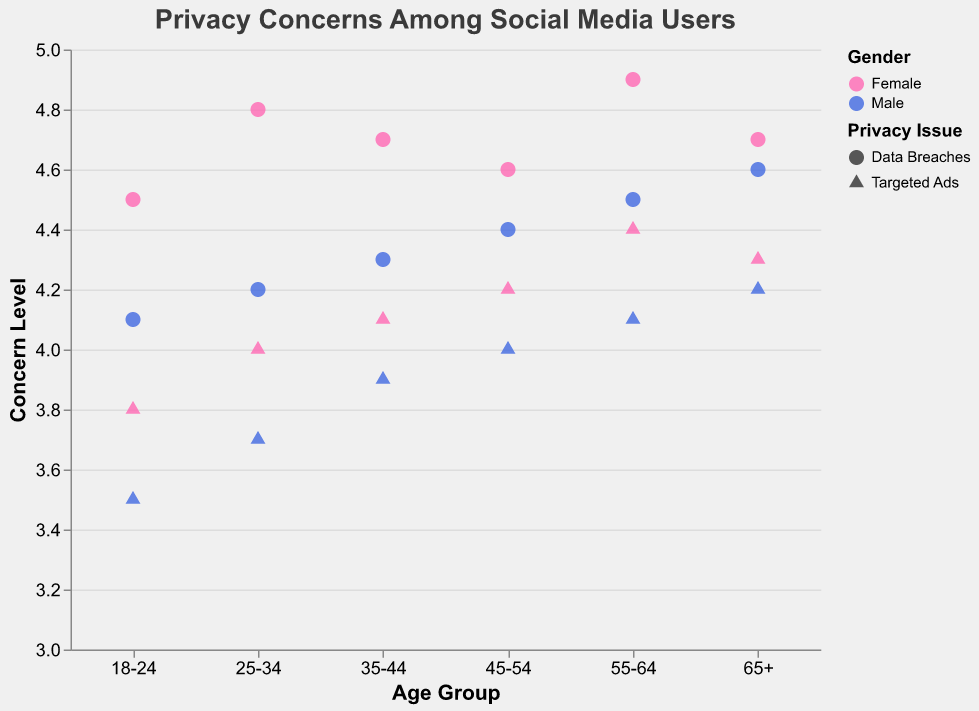What is the overall trend in concern levels for data breaches among different age groups? Look at the scatter plot and focus on the circles, which represent data breaches. Observe the vertical positions (Concern Level) of circles within each age group. You'll see that concern levels generally increase with older age groups.
Answer: Increasing with age Do males or females generally show higher concern levels for targeted ads? Refer to the triangles on the scatter plot, which represent targeted ads, and notice their vertical positions. Compare positions of pink triangles (females) with blue triangles (males). You'll see that females generally have higher concern levels for targeted ads.
Answer: Females Which age group has the highest level of concern for data breaches? Focus on circles (data breaches) in the scatter plot. Check for the highest vertical position. The 55-64 age group for both genders shows the highest concern for data breaches.
Answer: 55-64 What is the difference in concern levels for targeted ads between males aged 18-24 and males aged 45-54? Locate triangles (targeted ads) for males aged 18-24 and 45-54. Identify their positions on the vertical scale. The concern levels are 3.5 for 18-24 males and 4 for 45-54 males. Calculate 4 - 3.5 = 0.5.
Answer: 0.5 How do concern levels for targeted ads compare between females aged 25-34 and females aged 65+? Check triangles (targeted ads) for females aged 25-34 and 65+. Compare their vertical positions, which are 4.0 and 4.3, respectively. Females aged 65+ have higher concern levels (4.3 vs. 4.0).
Answer: 65+ have higher concern Which privacy issue has higher concern levels among males in the 35-44 age group? Look at both circles (data breaches) and triangles (targeted ads) in the 35-44 male age group. Compare their vertical positions. The circle (4.3) is higher than the triangle (3.9).
Answer: Data breaches What can be said about the trend in concern levels for targeted ads as people age? Observe triangles representing targeted ads across all age groups. Identify if there's an increasing or decreasing pattern. Generally, the concern level increases with age.
Answer: Generally increasing Is there a significant gender difference in concern levels for data breaches in the 25-34 age group? Compare circles (data breaches) for males and females within the 25-34 age group. Female concern level is 4.8, while male is 4.2. The difference (4.8 - 4.2) is 0.6, which is considerable.
Answer: Yes, females have higher concern What is the average concern level for females aged 35-44 regarding privacy issues? Check both data points for females aged 35-44. The concern levels are 4.7 (data breaches) and 4.1 (targeted ads). Calculate the average: (4.7 + 4.1) / 2 = 4.4.
Answer: 4.4 